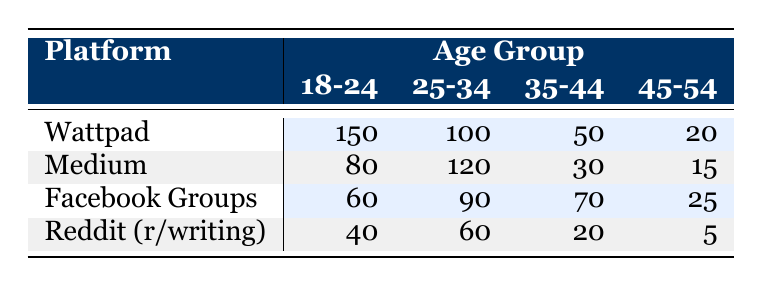What is the highest count of aspiring writers using Wattpad from the age group 18-24? According to the table, Wattpad has the highest count of 150 aspiring writers from the age group 18-24. This number can be directly retrieved from the corresponding cell in the table.
Answer: 150 What is the total count of aspiring writers aged 25-34 across all platforms? To calculate the total count for the age group 25-34, we sum the counts from each platform: Wattpad (100) + Medium (120) + Facebook Groups (90) + Reddit (r/writing) (60) = 370. Thus, the total count for the age group 25-34 is 370.
Answer: 370 Is there a higher count of aspiring writers aged 45-54 on Medium compared to Facebook Groups? Looking at the counts in the table, Medium has 15 while Facebook Groups has 25. Since 15 is less than 25, the answer is no.
Answer: No What is the average count of aspiring writers aged 18-24 across all platforms? To find the average: First, we sum the counts for the age group 18-24 from all platforms: Wattpad (150) + Medium (80) + Facebook Groups (60) + Reddit (r/writing) (40) = 330. Then, we divide by the number of platforms, which is 4: 330 / 4 = 82.5; thus, the average count is 82.5.
Answer: 82.5 Which platform has the lowest total count of aspiring writers in the age group 45-54? The counts for the age group 45-54 are: Wattpad (20), Medium (15), Facebook Groups (25), and Reddit (r/writing) (5). The lowest count is 5 from Reddit (r/writing).
Answer: Reddit (r/writing) What is the difference in the count of aspiring writers aged 35-44 between Wattpad and Medium? The count for 35-44 on Wattpad is 50 and on Medium is 30. The difference is calculated as 50 - 30 = 20. Thus, there are 20 more aspiring writers aged 35-44 on Wattpad compared to Medium.
Answer: 20 Are there more aspiring writers using Facebook Groups from the age group 25-34 than using Reddit (r/writing) from the same age group? From the table, Facebook Groups has 90 aspiring writers in the 25-34 age group, while Reddit (r/writing) has 60. Since 90 is greater than 60, the answer is yes.
Answer: Yes What is the total count of aspiring writers across all platforms for the age group 35-44? The counts for age group 35-44 are: Wattpad (50), Medium (30), Facebook Groups (70), and Reddit (r/writing) (20). We sum these values: 50 + 30 + 70 + 20 = 170. Thus, the total count for this age group is 170.
Answer: 170 